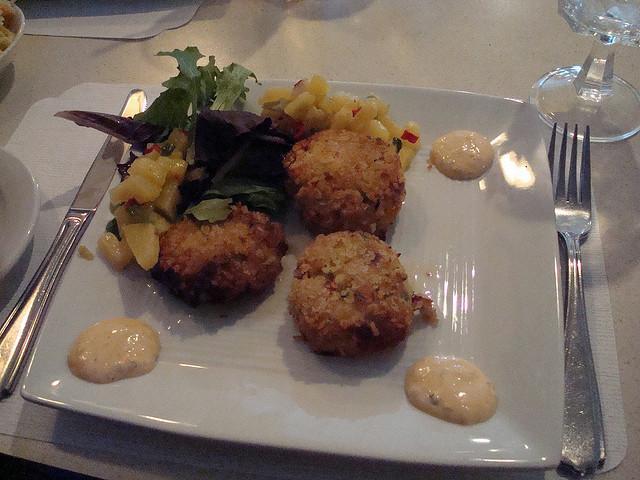How many spots of sauce are on the plate?
Give a very brief answer. 3. How many globs of sauce are visible?
Give a very brief answer. 3. How many forks are there?
Give a very brief answer. 1. How many sandwiches are visible?
Give a very brief answer. 3. How many drinks cups have straw?
Give a very brief answer. 0. 